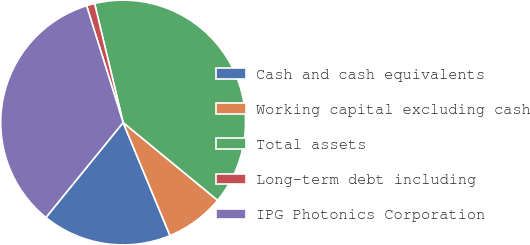<chart> <loc_0><loc_0><loc_500><loc_500><pie_chart><fcel>Cash and cash equivalents<fcel>Working capital excluding cash<fcel>Total assets<fcel>Long-term debt including<fcel>IPG Photonics Corporation<nl><fcel>17.12%<fcel>7.79%<fcel>39.7%<fcel>1.08%<fcel>34.31%<nl></chart> 